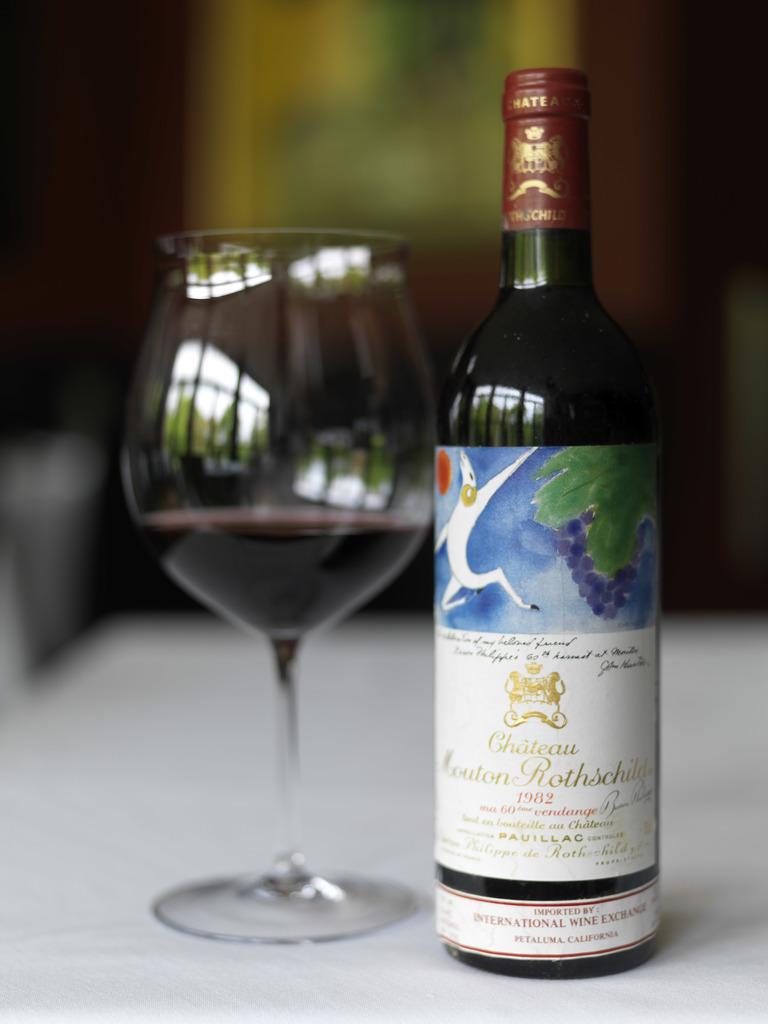Please provide a concise description of this image. In this picture there is a wine bottle with wine glass kept beside it on a table 